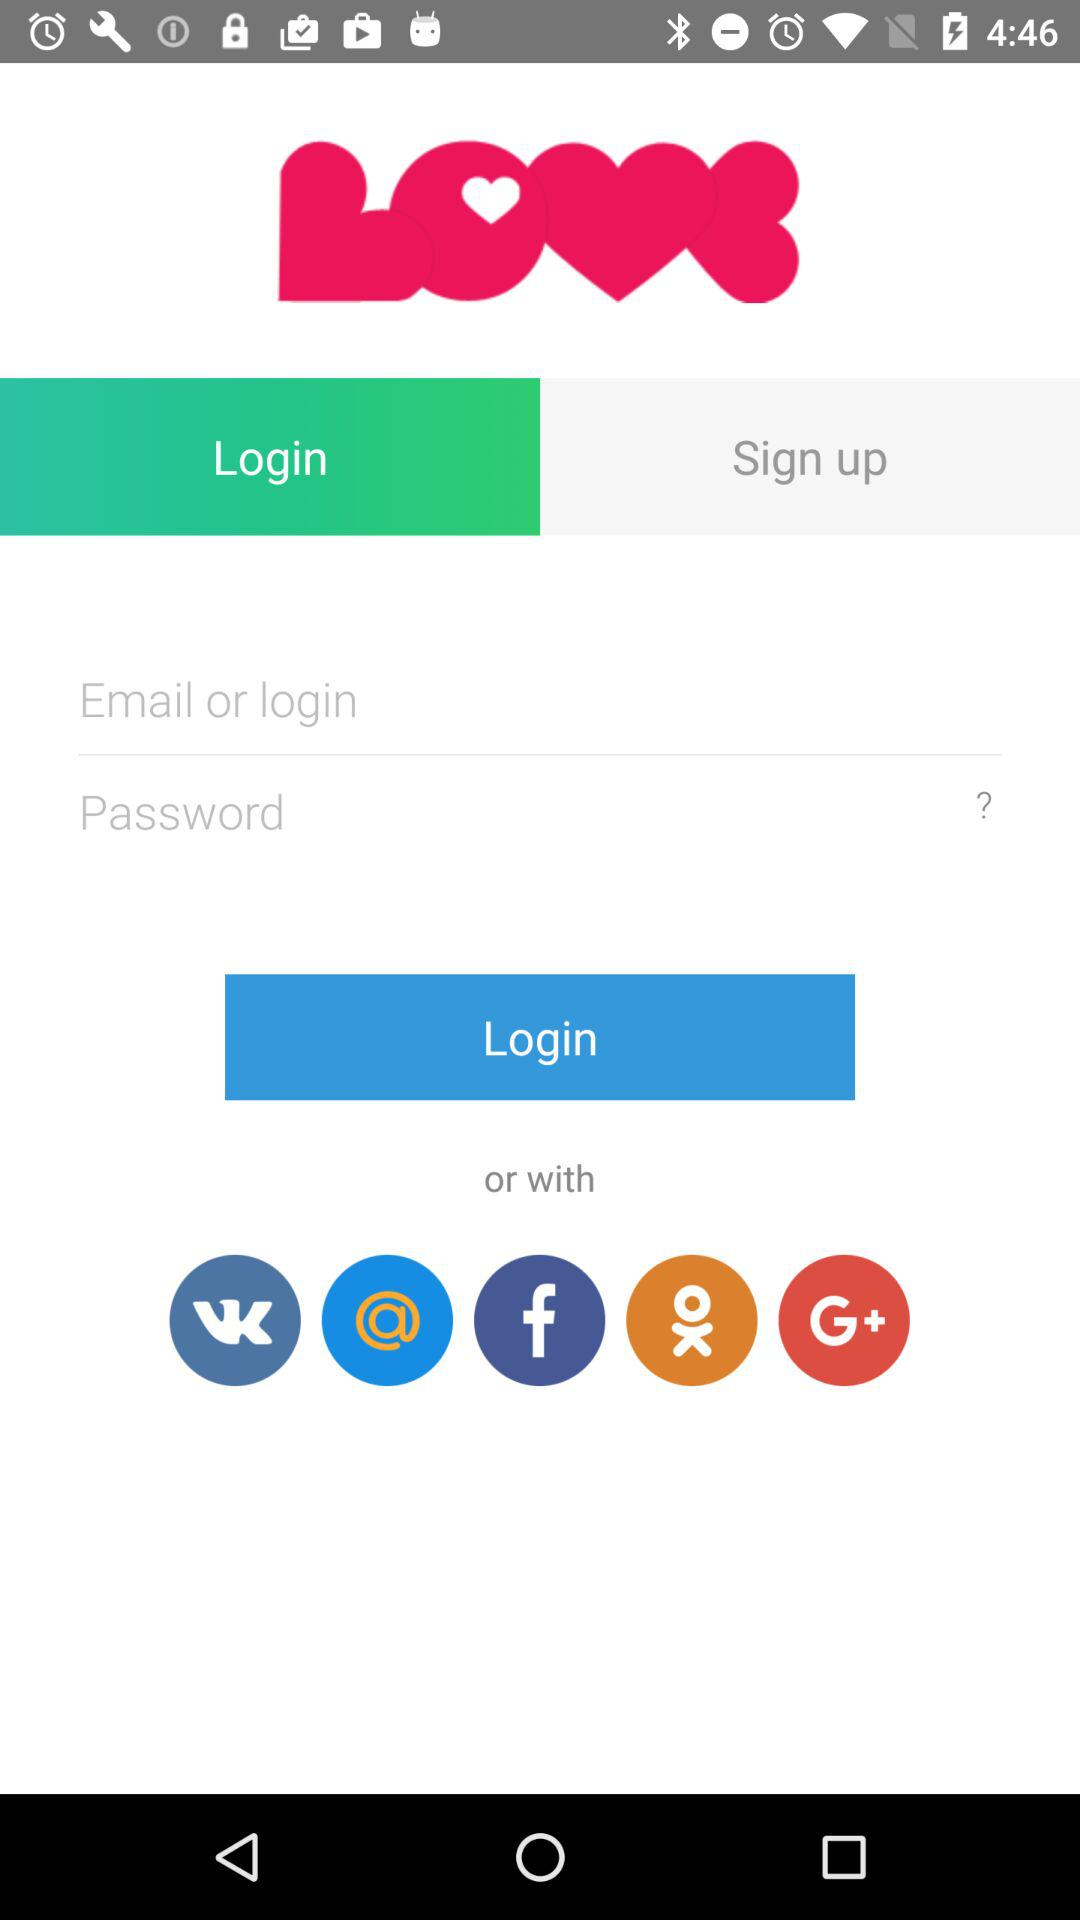How many input fields are there for logging in?
Answer the question using a single word or phrase. 2 